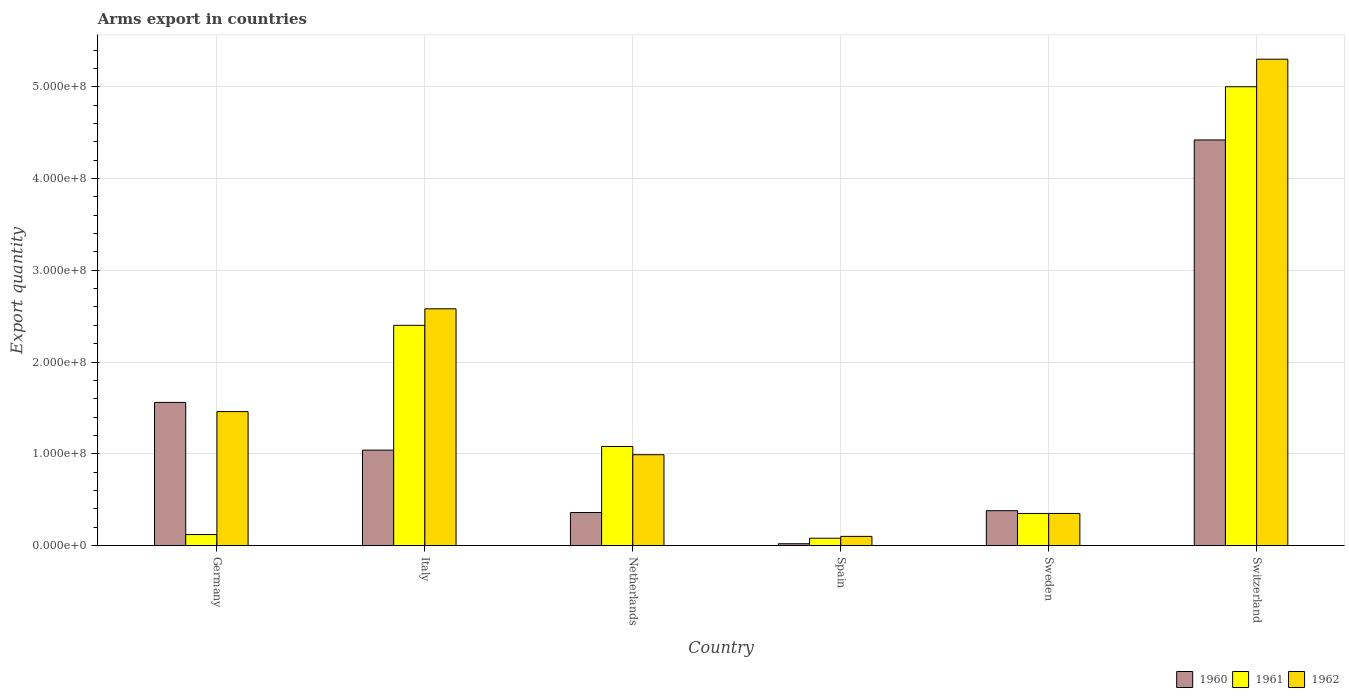How many different coloured bars are there?
Your answer should be compact. 3. In how many cases, is the number of bars for a given country not equal to the number of legend labels?
Your response must be concise. 0. What is the total arms export in 1961 in Germany?
Your answer should be compact. 1.20e+07. Across all countries, what is the maximum total arms export in 1961?
Give a very brief answer. 5.00e+08. Across all countries, what is the minimum total arms export in 1960?
Give a very brief answer. 2.00e+06. In which country was the total arms export in 1961 maximum?
Provide a short and direct response. Switzerland. What is the total total arms export in 1962 in the graph?
Keep it short and to the point. 1.08e+09. What is the difference between the total arms export in 1960 in Germany and that in Italy?
Your answer should be very brief. 5.20e+07. What is the difference between the total arms export in 1961 in Germany and the total arms export in 1960 in Sweden?
Your response must be concise. -2.60e+07. What is the average total arms export in 1960 per country?
Ensure brevity in your answer.  1.30e+08. What is the difference between the total arms export of/in 1960 and total arms export of/in 1961 in Switzerland?
Your answer should be very brief. -5.80e+07. In how many countries, is the total arms export in 1961 greater than 220000000?
Give a very brief answer. 2. What is the ratio of the total arms export in 1962 in Germany to that in Sweden?
Your answer should be very brief. 4.17. What is the difference between the highest and the second highest total arms export in 1962?
Give a very brief answer. 3.84e+08. What is the difference between the highest and the lowest total arms export in 1960?
Make the answer very short. 4.40e+08. In how many countries, is the total arms export in 1960 greater than the average total arms export in 1960 taken over all countries?
Offer a very short reply. 2. What does the 1st bar from the left in Sweden represents?
Your answer should be very brief. 1960. Is it the case that in every country, the sum of the total arms export in 1961 and total arms export in 1962 is greater than the total arms export in 1960?
Ensure brevity in your answer.  Yes. How many bars are there?
Offer a very short reply. 18. Are all the bars in the graph horizontal?
Provide a succinct answer. No. How many countries are there in the graph?
Your answer should be very brief. 6. Are the values on the major ticks of Y-axis written in scientific E-notation?
Ensure brevity in your answer.  Yes. Does the graph contain any zero values?
Provide a succinct answer. No. Where does the legend appear in the graph?
Your answer should be very brief. Bottom right. What is the title of the graph?
Give a very brief answer. Arms export in countries. Does "1983" appear as one of the legend labels in the graph?
Make the answer very short. No. What is the label or title of the X-axis?
Your answer should be very brief. Country. What is the label or title of the Y-axis?
Offer a terse response. Export quantity. What is the Export quantity of 1960 in Germany?
Your answer should be very brief. 1.56e+08. What is the Export quantity of 1961 in Germany?
Make the answer very short. 1.20e+07. What is the Export quantity in 1962 in Germany?
Ensure brevity in your answer.  1.46e+08. What is the Export quantity in 1960 in Italy?
Make the answer very short. 1.04e+08. What is the Export quantity of 1961 in Italy?
Provide a succinct answer. 2.40e+08. What is the Export quantity in 1962 in Italy?
Make the answer very short. 2.58e+08. What is the Export quantity of 1960 in Netherlands?
Make the answer very short. 3.60e+07. What is the Export quantity of 1961 in Netherlands?
Offer a terse response. 1.08e+08. What is the Export quantity in 1962 in Netherlands?
Provide a succinct answer. 9.90e+07. What is the Export quantity of 1960 in Sweden?
Offer a very short reply. 3.80e+07. What is the Export quantity in 1961 in Sweden?
Your answer should be compact. 3.50e+07. What is the Export quantity in 1962 in Sweden?
Provide a succinct answer. 3.50e+07. What is the Export quantity of 1960 in Switzerland?
Keep it short and to the point. 4.42e+08. What is the Export quantity of 1961 in Switzerland?
Your response must be concise. 5.00e+08. What is the Export quantity in 1962 in Switzerland?
Offer a very short reply. 5.30e+08. Across all countries, what is the maximum Export quantity of 1960?
Offer a very short reply. 4.42e+08. Across all countries, what is the maximum Export quantity of 1962?
Provide a succinct answer. 5.30e+08. Across all countries, what is the minimum Export quantity of 1960?
Provide a succinct answer. 2.00e+06. What is the total Export quantity of 1960 in the graph?
Your answer should be compact. 7.78e+08. What is the total Export quantity in 1961 in the graph?
Ensure brevity in your answer.  9.03e+08. What is the total Export quantity in 1962 in the graph?
Offer a very short reply. 1.08e+09. What is the difference between the Export quantity in 1960 in Germany and that in Italy?
Your response must be concise. 5.20e+07. What is the difference between the Export quantity in 1961 in Germany and that in Italy?
Your answer should be very brief. -2.28e+08. What is the difference between the Export quantity of 1962 in Germany and that in Italy?
Offer a very short reply. -1.12e+08. What is the difference between the Export quantity in 1960 in Germany and that in Netherlands?
Provide a short and direct response. 1.20e+08. What is the difference between the Export quantity of 1961 in Germany and that in Netherlands?
Offer a very short reply. -9.60e+07. What is the difference between the Export quantity in 1962 in Germany and that in Netherlands?
Offer a terse response. 4.70e+07. What is the difference between the Export quantity of 1960 in Germany and that in Spain?
Give a very brief answer. 1.54e+08. What is the difference between the Export quantity of 1961 in Germany and that in Spain?
Offer a terse response. 4.00e+06. What is the difference between the Export quantity of 1962 in Germany and that in Spain?
Your answer should be compact. 1.36e+08. What is the difference between the Export quantity in 1960 in Germany and that in Sweden?
Make the answer very short. 1.18e+08. What is the difference between the Export quantity in 1961 in Germany and that in Sweden?
Offer a terse response. -2.30e+07. What is the difference between the Export quantity in 1962 in Germany and that in Sweden?
Keep it short and to the point. 1.11e+08. What is the difference between the Export quantity of 1960 in Germany and that in Switzerland?
Your answer should be very brief. -2.86e+08. What is the difference between the Export quantity in 1961 in Germany and that in Switzerland?
Give a very brief answer. -4.88e+08. What is the difference between the Export quantity in 1962 in Germany and that in Switzerland?
Keep it short and to the point. -3.84e+08. What is the difference between the Export quantity of 1960 in Italy and that in Netherlands?
Make the answer very short. 6.80e+07. What is the difference between the Export quantity of 1961 in Italy and that in Netherlands?
Make the answer very short. 1.32e+08. What is the difference between the Export quantity in 1962 in Italy and that in Netherlands?
Your response must be concise. 1.59e+08. What is the difference between the Export quantity in 1960 in Italy and that in Spain?
Your answer should be compact. 1.02e+08. What is the difference between the Export quantity of 1961 in Italy and that in Spain?
Offer a terse response. 2.32e+08. What is the difference between the Export quantity of 1962 in Italy and that in Spain?
Give a very brief answer. 2.48e+08. What is the difference between the Export quantity in 1960 in Italy and that in Sweden?
Your response must be concise. 6.60e+07. What is the difference between the Export quantity of 1961 in Italy and that in Sweden?
Offer a terse response. 2.05e+08. What is the difference between the Export quantity in 1962 in Italy and that in Sweden?
Offer a very short reply. 2.23e+08. What is the difference between the Export quantity of 1960 in Italy and that in Switzerland?
Give a very brief answer. -3.38e+08. What is the difference between the Export quantity of 1961 in Italy and that in Switzerland?
Your response must be concise. -2.60e+08. What is the difference between the Export quantity in 1962 in Italy and that in Switzerland?
Offer a very short reply. -2.72e+08. What is the difference between the Export quantity in 1960 in Netherlands and that in Spain?
Provide a succinct answer. 3.40e+07. What is the difference between the Export quantity of 1961 in Netherlands and that in Spain?
Provide a succinct answer. 1.00e+08. What is the difference between the Export quantity of 1962 in Netherlands and that in Spain?
Your response must be concise. 8.90e+07. What is the difference between the Export quantity of 1961 in Netherlands and that in Sweden?
Make the answer very short. 7.30e+07. What is the difference between the Export quantity in 1962 in Netherlands and that in Sweden?
Provide a succinct answer. 6.40e+07. What is the difference between the Export quantity of 1960 in Netherlands and that in Switzerland?
Your answer should be very brief. -4.06e+08. What is the difference between the Export quantity of 1961 in Netherlands and that in Switzerland?
Give a very brief answer. -3.92e+08. What is the difference between the Export quantity of 1962 in Netherlands and that in Switzerland?
Provide a succinct answer. -4.31e+08. What is the difference between the Export quantity of 1960 in Spain and that in Sweden?
Your answer should be compact. -3.60e+07. What is the difference between the Export quantity in 1961 in Spain and that in Sweden?
Your answer should be compact. -2.70e+07. What is the difference between the Export quantity of 1962 in Spain and that in Sweden?
Give a very brief answer. -2.50e+07. What is the difference between the Export quantity in 1960 in Spain and that in Switzerland?
Provide a short and direct response. -4.40e+08. What is the difference between the Export quantity in 1961 in Spain and that in Switzerland?
Your answer should be compact. -4.92e+08. What is the difference between the Export quantity of 1962 in Spain and that in Switzerland?
Offer a very short reply. -5.20e+08. What is the difference between the Export quantity of 1960 in Sweden and that in Switzerland?
Provide a short and direct response. -4.04e+08. What is the difference between the Export quantity of 1961 in Sweden and that in Switzerland?
Your answer should be very brief. -4.65e+08. What is the difference between the Export quantity of 1962 in Sweden and that in Switzerland?
Give a very brief answer. -4.95e+08. What is the difference between the Export quantity in 1960 in Germany and the Export quantity in 1961 in Italy?
Your answer should be compact. -8.40e+07. What is the difference between the Export quantity in 1960 in Germany and the Export quantity in 1962 in Italy?
Keep it short and to the point. -1.02e+08. What is the difference between the Export quantity of 1961 in Germany and the Export quantity of 1962 in Italy?
Give a very brief answer. -2.46e+08. What is the difference between the Export quantity of 1960 in Germany and the Export quantity of 1961 in Netherlands?
Your answer should be very brief. 4.80e+07. What is the difference between the Export quantity in 1960 in Germany and the Export quantity in 1962 in Netherlands?
Offer a very short reply. 5.70e+07. What is the difference between the Export quantity in 1961 in Germany and the Export quantity in 1962 in Netherlands?
Offer a terse response. -8.70e+07. What is the difference between the Export quantity of 1960 in Germany and the Export quantity of 1961 in Spain?
Provide a short and direct response. 1.48e+08. What is the difference between the Export quantity of 1960 in Germany and the Export quantity of 1962 in Spain?
Give a very brief answer. 1.46e+08. What is the difference between the Export quantity in 1961 in Germany and the Export quantity in 1962 in Spain?
Your answer should be very brief. 2.00e+06. What is the difference between the Export quantity of 1960 in Germany and the Export quantity of 1961 in Sweden?
Provide a short and direct response. 1.21e+08. What is the difference between the Export quantity in 1960 in Germany and the Export quantity in 1962 in Sweden?
Your answer should be very brief. 1.21e+08. What is the difference between the Export quantity of 1961 in Germany and the Export quantity of 1962 in Sweden?
Make the answer very short. -2.30e+07. What is the difference between the Export quantity of 1960 in Germany and the Export quantity of 1961 in Switzerland?
Offer a very short reply. -3.44e+08. What is the difference between the Export quantity of 1960 in Germany and the Export quantity of 1962 in Switzerland?
Offer a terse response. -3.74e+08. What is the difference between the Export quantity of 1961 in Germany and the Export quantity of 1962 in Switzerland?
Keep it short and to the point. -5.18e+08. What is the difference between the Export quantity in 1961 in Italy and the Export quantity in 1962 in Netherlands?
Your response must be concise. 1.41e+08. What is the difference between the Export quantity in 1960 in Italy and the Export quantity in 1961 in Spain?
Offer a very short reply. 9.60e+07. What is the difference between the Export quantity of 1960 in Italy and the Export quantity of 1962 in Spain?
Make the answer very short. 9.40e+07. What is the difference between the Export quantity in 1961 in Italy and the Export quantity in 1962 in Spain?
Your answer should be compact. 2.30e+08. What is the difference between the Export quantity of 1960 in Italy and the Export quantity of 1961 in Sweden?
Your answer should be compact. 6.90e+07. What is the difference between the Export quantity of 1960 in Italy and the Export quantity of 1962 in Sweden?
Your answer should be very brief. 6.90e+07. What is the difference between the Export quantity in 1961 in Italy and the Export quantity in 1962 in Sweden?
Give a very brief answer. 2.05e+08. What is the difference between the Export quantity of 1960 in Italy and the Export quantity of 1961 in Switzerland?
Your answer should be compact. -3.96e+08. What is the difference between the Export quantity in 1960 in Italy and the Export quantity in 1962 in Switzerland?
Offer a terse response. -4.26e+08. What is the difference between the Export quantity in 1961 in Italy and the Export quantity in 1962 in Switzerland?
Offer a terse response. -2.90e+08. What is the difference between the Export quantity in 1960 in Netherlands and the Export quantity in 1961 in Spain?
Your answer should be compact. 2.80e+07. What is the difference between the Export quantity of 1960 in Netherlands and the Export quantity of 1962 in Spain?
Your response must be concise. 2.60e+07. What is the difference between the Export quantity in 1961 in Netherlands and the Export quantity in 1962 in Spain?
Offer a terse response. 9.80e+07. What is the difference between the Export quantity in 1960 in Netherlands and the Export quantity in 1961 in Sweden?
Your answer should be compact. 1.00e+06. What is the difference between the Export quantity in 1961 in Netherlands and the Export quantity in 1962 in Sweden?
Give a very brief answer. 7.30e+07. What is the difference between the Export quantity of 1960 in Netherlands and the Export quantity of 1961 in Switzerland?
Your answer should be very brief. -4.64e+08. What is the difference between the Export quantity in 1960 in Netherlands and the Export quantity in 1962 in Switzerland?
Ensure brevity in your answer.  -4.94e+08. What is the difference between the Export quantity of 1961 in Netherlands and the Export quantity of 1962 in Switzerland?
Keep it short and to the point. -4.22e+08. What is the difference between the Export quantity in 1960 in Spain and the Export quantity in 1961 in Sweden?
Provide a succinct answer. -3.30e+07. What is the difference between the Export quantity in 1960 in Spain and the Export quantity in 1962 in Sweden?
Your response must be concise. -3.30e+07. What is the difference between the Export quantity in 1961 in Spain and the Export quantity in 1962 in Sweden?
Offer a very short reply. -2.70e+07. What is the difference between the Export quantity in 1960 in Spain and the Export quantity in 1961 in Switzerland?
Keep it short and to the point. -4.98e+08. What is the difference between the Export quantity of 1960 in Spain and the Export quantity of 1962 in Switzerland?
Your response must be concise. -5.28e+08. What is the difference between the Export quantity of 1961 in Spain and the Export quantity of 1962 in Switzerland?
Your response must be concise. -5.22e+08. What is the difference between the Export quantity of 1960 in Sweden and the Export quantity of 1961 in Switzerland?
Your answer should be very brief. -4.62e+08. What is the difference between the Export quantity of 1960 in Sweden and the Export quantity of 1962 in Switzerland?
Ensure brevity in your answer.  -4.92e+08. What is the difference between the Export quantity in 1961 in Sweden and the Export quantity in 1962 in Switzerland?
Offer a terse response. -4.95e+08. What is the average Export quantity in 1960 per country?
Your response must be concise. 1.30e+08. What is the average Export quantity in 1961 per country?
Your response must be concise. 1.50e+08. What is the average Export quantity in 1962 per country?
Keep it short and to the point. 1.80e+08. What is the difference between the Export quantity of 1960 and Export quantity of 1961 in Germany?
Make the answer very short. 1.44e+08. What is the difference between the Export quantity in 1961 and Export quantity in 1962 in Germany?
Give a very brief answer. -1.34e+08. What is the difference between the Export quantity in 1960 and Export quantity in 1961 in Italy?
Keep it short and to the point. -1.36e+08. What is the difference between the Export quantity of 1960 and Export quantity of 1962 in Italy?
Your answer should be very brief. -1.54e+08. What is the difference between the Export quantity of 1961 and Export quantity of 1962 in Italy?
Offer a very short reply. -1.80e+07. What is the difference between the Export quantity of 1960 and Export quantity of 1961 in Netherlands?
Make the answer very short. -7.20e+07. What is the difference between the Export quantity of 1960 and Export quantity of 1962 in Netherlands?
Make the answer very short. -6.30e+07. What is the difference between the Export quantity in 1961 and Export quantity in 1962 in Netherlands?
Ensure brevity in your answer.  9.00e+06. What is the difference between the Export quantity of 1960 and Export quantity of 1961 in Spain?
Give a very brief answer. -6.00e+06. What is the difference between the Export quantity in 1960 and Export quantity in 1962 in Spain?
Keep it short and to the point. -8.00e+06. What is the difference between the Export quantity of 1961 and Export quantity of 1962 in Spain?
Offer a terse response. -2.00e+06. What is the difference between the Export quantity of 1960 and Export quantity of 1961 in Sweden?
Provide a short and direct response. 3.00e+06. What is the difference between the Export quantity in 1960 and Export quantity in 1962 in Sweden?
Ensure brevity in your answer.  3.00e+06. What is the difference between the Export quantity of 1960 and Export quantity of 1961 in Switzerland?
Keep it short and to the point. -5.80e+07. What is the difference between the Export quantity of 1960 and Export quantity of 1962 in Switzerland?
Your answer should be compact. -8.80e+07. What is the difference between the Export quantity in 1961 and Export quantity in 1962 in Switzerland?
Provide a short and direct response. -3.00e+07. What is the ratio of the Export quantity of 1960 in Germany to that in Italy?
Your response must be concise. 1.5. What is the ratio of the Export quantity in 1961 in Germany to that in Italy?
Your answer should be compact. 0.05. What is the ratio of the Export quantity of 1962 in Germany to that in Italy?
Offer a very short reply. 0.57. What is the ratio of the Export quantity of 1960 in Germany to that in Netherlands?
Offer a terse response. 4.33. What is the ratio of the Export quantity in 1962 in Germany to that in Netherlands?
Provide a short and direct response. 1.47. What is the ratio of the Export quantity of 1960 in Germany to that in Spain?
Provide a succinct answer. 78. What is the ratio of the Export quantity in 1961 in Germany to that in Spain?
Offer a very short reply. 1.5. What is the ratio of the Export quantity in 1962 in Germany to that in Spain?
Your answer should be compact. 14.6. What is the ratio of the Export quantity in 1960 in Germany to that in Sweden?
Offer a terse response. 4.11. What is the ratio of the Export quantity of 1961 in Germany to that in Sweden?
Give a very brief answer. 0.34. What is the ratio of the Export quantity in 1962 in Germany to that in Sweden?
Make the answer very short. 4.17. What is the ratio of the Export quantity in 1960 in Germany to that in Switzerland?
Offer a very short reply. 0.35. What is the ratio of the Export quantity in 1961 in Germany to that in Switzerland?
Your response must be concise. 0.02. What is the ratio of the Export quantity in 1962 in Germany to that in Switzerland?
Provide a short and direct response. 0.28. What is the ratio of the Export quantity of 1960 in Italy to that in Netherlands?
Your answer should be compact. 2.89. What is the ratio of the Export quantity of 1961 in Italy to that in Netherlands?
Give a very brief answer. 2.22. What is the ratio of the Export quantity in 1962 in Italy to that in Netherlands?
Ensure brevity in your answer.  2.61. What is the ratio of the Export quantity in 1962 in Italy to that in Spain?
Keep it short and to the point. 25.8. What is the ratio of the Export quantity in 1960 in Italy to that in Sweden?
Provide a short and direct response. 2.74. What is the ratio of the Export quantity in 1961 in Italy to that in Sweden?
Offer a very short reply. 6.86. What is the ratio of the Export quantity in 1962 in Italy to that in Sweden?
Your answer should be compact. 7.37. What is the ratio of the Export quantity in 1960 in Italy to that in Switzerland?
Your answer should be compact. 0.24. What is the ratio of the Export quantity of 1961 in Italy to that in Switzerland?
Provide a succinct answer. 0.48. What is the ratio of the Export quantity of 1962 in Italy to that in Switzerland?
Offer a terse response. 0.49. What is the ratio of the Export quantity in 1960 in Netherlands to that in Spain?
Offer a very short reply. 18. What is the ratio of the Export quantity in 1961 in Netherlands to that in Sweden?
Offer a very short reply. 3.09. What is the ratio of the Export quantity of 1962 in Netherlands to that in Sweden?
Make the answer very short. 2.83. What is the ratio of the Export quantity in 1960 in Netherlands to that in Switzerland?
Ensure brevity in your answer.  0.08. What is the ratio of the Export quantity in 1961 in Netherlands to that in Switzerland?
Keep it short and to the point. 0.22. What is the ratio of the Export quantity of 1962 in Netherlands to that in Switzerland?
Your answer should be very brief. 0.19. What is the ratio of the Export quantity of 1960 in Spain to that in Sweden?
Make the answer very short. 0.05. What is the ratio of the Export quantity in 1961 in Spain to that in Sweden?
Offer a terse response. 0.23. What is the ratio of the Export quantity in 1962 in Spain to that in Sweden?
Keep it short and to the point. 0.29. What is the ratio of the Export quantity of 1960 in Spain to that in Switzerland?
Give a very brief answer. 0. What is the ratio of the Export quantity of 1961 in Spain to that in Switzerland?
Your response must be concise. 0.02. What is the ratio of the Export quantity of 1962 in Spain to that in Switzerland?
Provide a succinct answer. 0.02. What is the ratio of the Export quantity in 1960 in Sweden to that in Switzerland?
Your answer should be compact. 0.09. What is the ratio of the Export quantity of 1961 in Sweden to that in Switzerland?
Keep it short and to the point. 0.07. What is the ratio of the Export quantity in 1962 in Sweden to that in Switzerland?
Give a very brief answer. 0.07. What is the difference between the highest and the second highest Export quantity in 1960?
Your answer should be very brief. 2.86e+08. What is the difference between the highest and the second highest Export quantity in 1961?
Your response must be concise. 2.60e+08. What is the difference between the highest and the second highest Export quantity of 1962?
Keep it short and to the point. 2.72e+08. What is the difference between the highest and the lowest Export quantity of 1960?
Your response must be concise. 4.40e+08. What is the difference between the highest and the lowest Export quantity in 1961?
Your answer should be very brief. 4.92e+08. What is the difference between the highest and the lowest Export quantity of 1962?
Keep it short and to the point. 5.20e+08. 